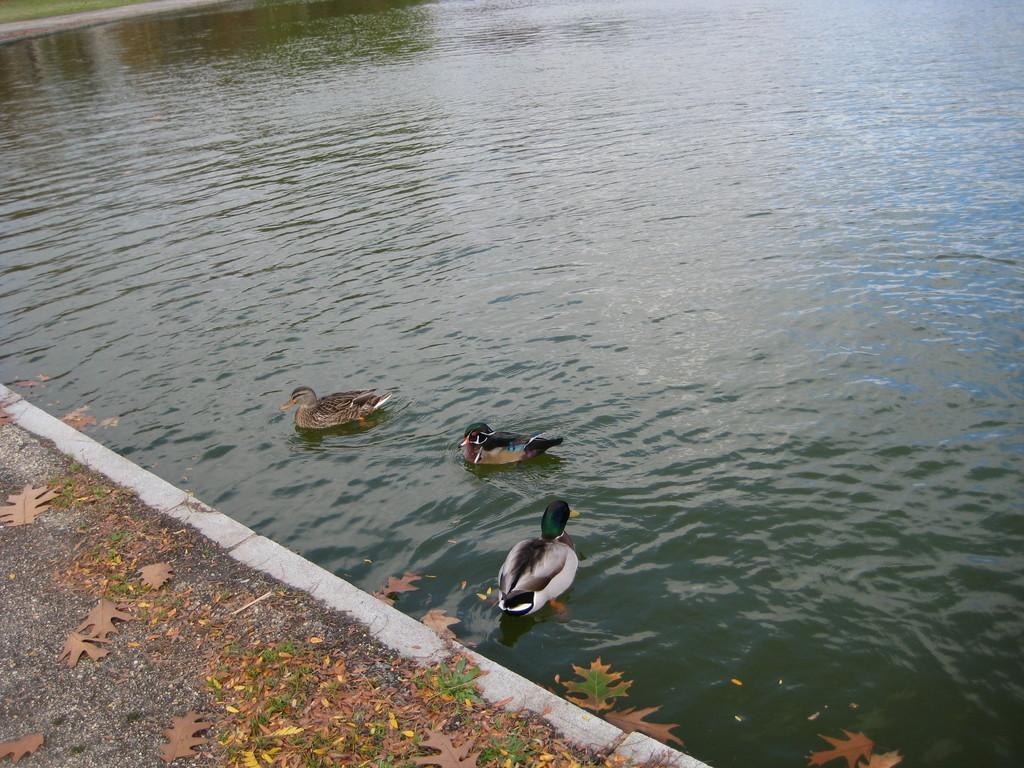How would you summarize this image in a sentence or two? In this image, we can see ducks in the water. There are some dry leaves on the ground. 